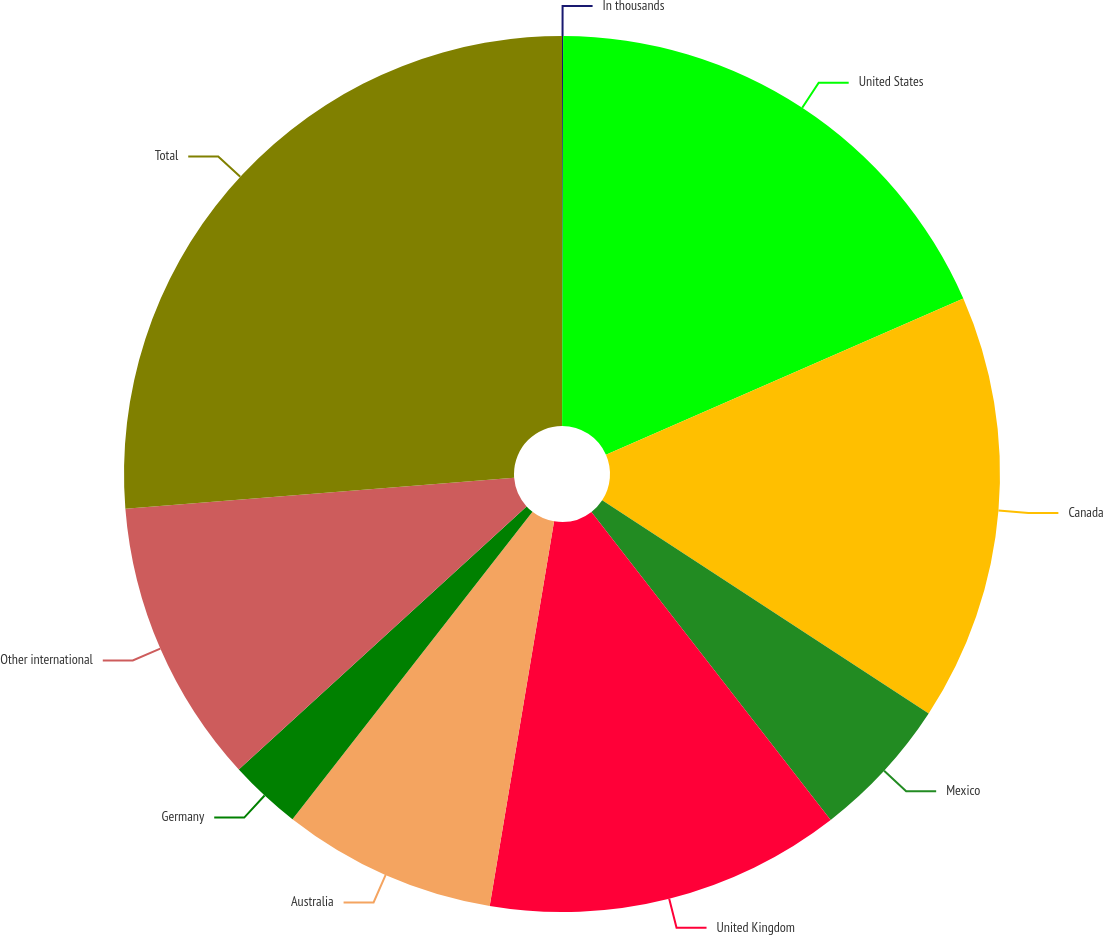<chart> <loc_0><loc_0><loc_500><loc_500><pie_chart><fcel>In thousands<fcel>United States<fcel>Canada<fcel>Mexico<fcel>United Kingdom<fcel>Australia<fcel>Germany<fcel>Other international<fcel>Total<nl><fcel>0.04%<fcel>18.4%<fcel>15.77%<fcel>5.28%<fcel>13.15%<fcel>7.91%<fcel>2.66%<fcel>10.53%<fcel>26.26%<nl></chart> 